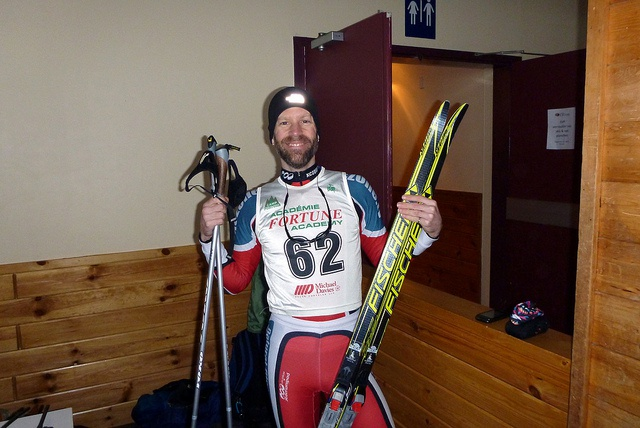Describe the objects in this image and their specific colors. I can see people in gray, lightgray, brown, black, and darkgray tones, skis in gray, black, olive, and maroon tones, backpack in gray, black, maroon, and darkblue tones, and cell phone in gray, black, and maroon tones in this image. 